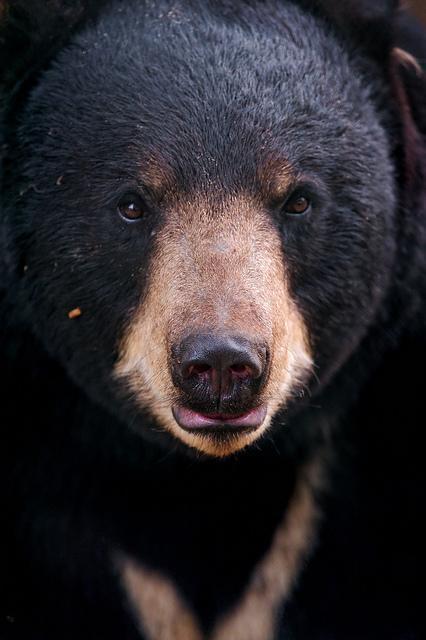How many bowls contain red foods?
Give a very brief answer. 0. 